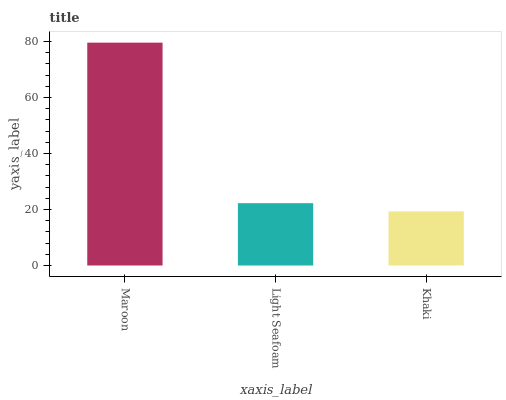Is Khaki the minimum?
Answer yes or no. Yes. Is Maroon the maximum?
Answer yes or no. Yes. Is Light Seafoam the minimum?
Answer yes or no. No. Is Light Seafoam the maximum?
Answer yes or no. No. Is Maroon greater than Light Seafoam?
Answer yes or no. Yes. Is Light Seafoam less than Maroon?
Answer yes or no. Yes. Is Light Seafoam greater than Maroon?
Answer yes or no. No. Is Maroon less than Light Seafoam?
Answer yes or no. No. Is Light Seafoam the high median?
Answer yes or no. Yes. Is Light Seafoam the low median?
Answer yes or no. Yes. Is Maroon the high median?
Answer yes or no. No. Is Khaki the low median?
Answer yes or no. No. 